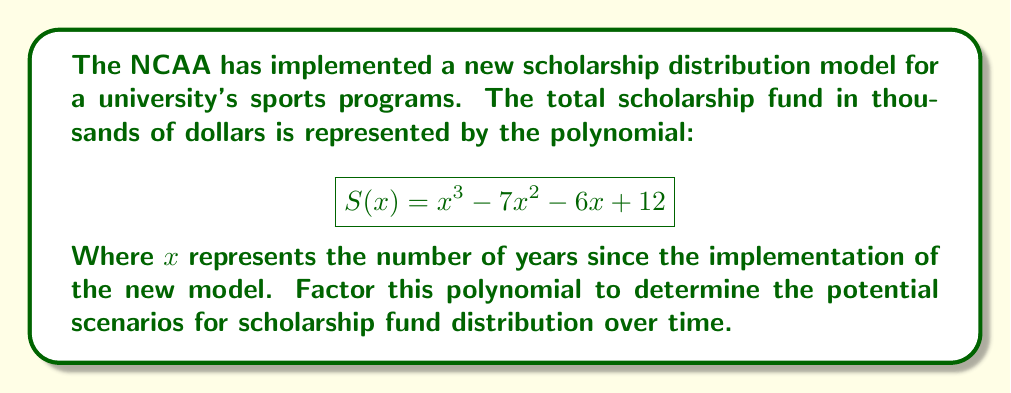Can you answer this question? To factor this polynomial, we'll follow these steps:

1) First, let's check if there's a common factor. In this case, there isn't.

2) Next, we'll try to guess one of the factors. A factor of the constant term (12) could be a root. Let's try some factors of 12: ±1, ±2, ±3, ±4, ±6, ±12.

3) Using synthetic division, we find that -2 is a root:

   $$ 1 | -7 | -6 | 12 $$
   $$ -2 | -2 | 18 | -24 $$
   $$ 1 | -9 | 12 | 0 $$

4) This means $(x+2)$ is a factor, and we can write:

   $$S(x) = (x+2)(x^2 - 9x + 6)$$

5) Now we need to factor the quadratic $x^2 - 9x + 6$. We can do this by finding two numbers that multiply to give 6 and add to give -9. These numbers are -3 and -6.

6) Therefore, we can factor further:

   $$S(x) = (x+2)(x-3)(x-6)$$

This is the fully factored form of the polynomial.
Answer: $(x+2)(x-3)(x-6)$ 